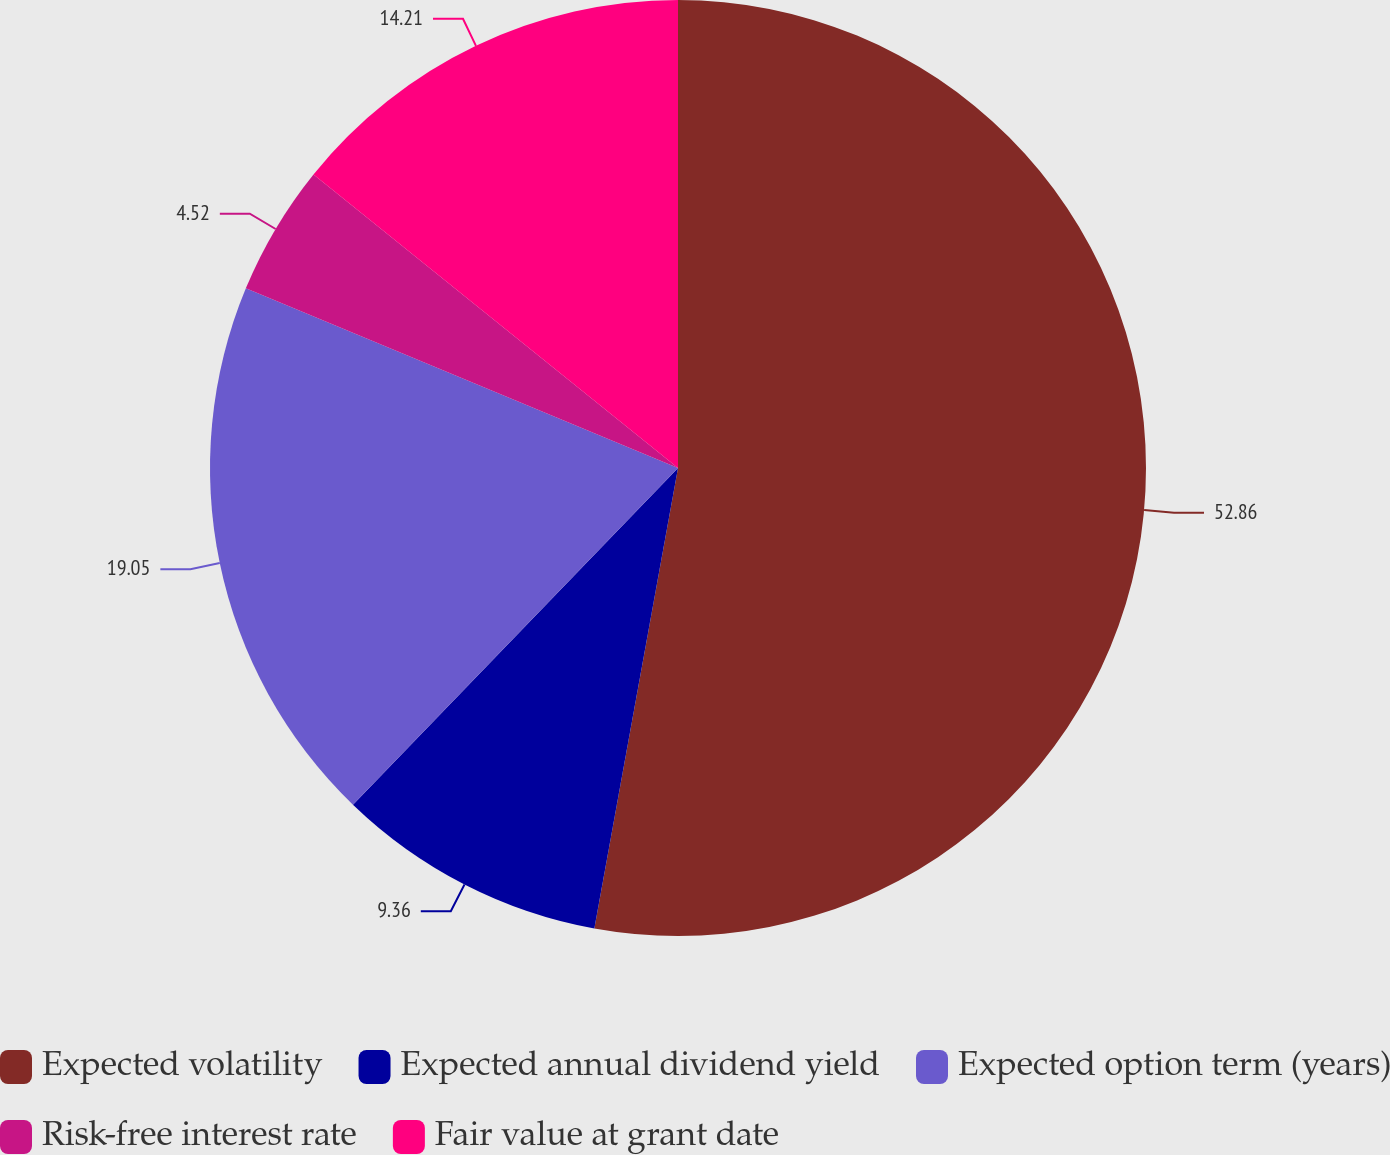<chart> <loc_0><loc_0><loc_500><loc_500><pie_chart><fcel>Expected volatility<fcel>Expected annual dividend yield<fcel>Expected option term (years)<fcel>Risk-free interest rate<fcel>Fair value at grant date<nl><fcel>52.86%<fcel>9.36%<fcel>19.05%<fcel>4.52%<fcel>14.21%<nl></chart> 